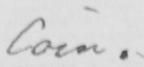What text is written in this handwritten line? Coin . 